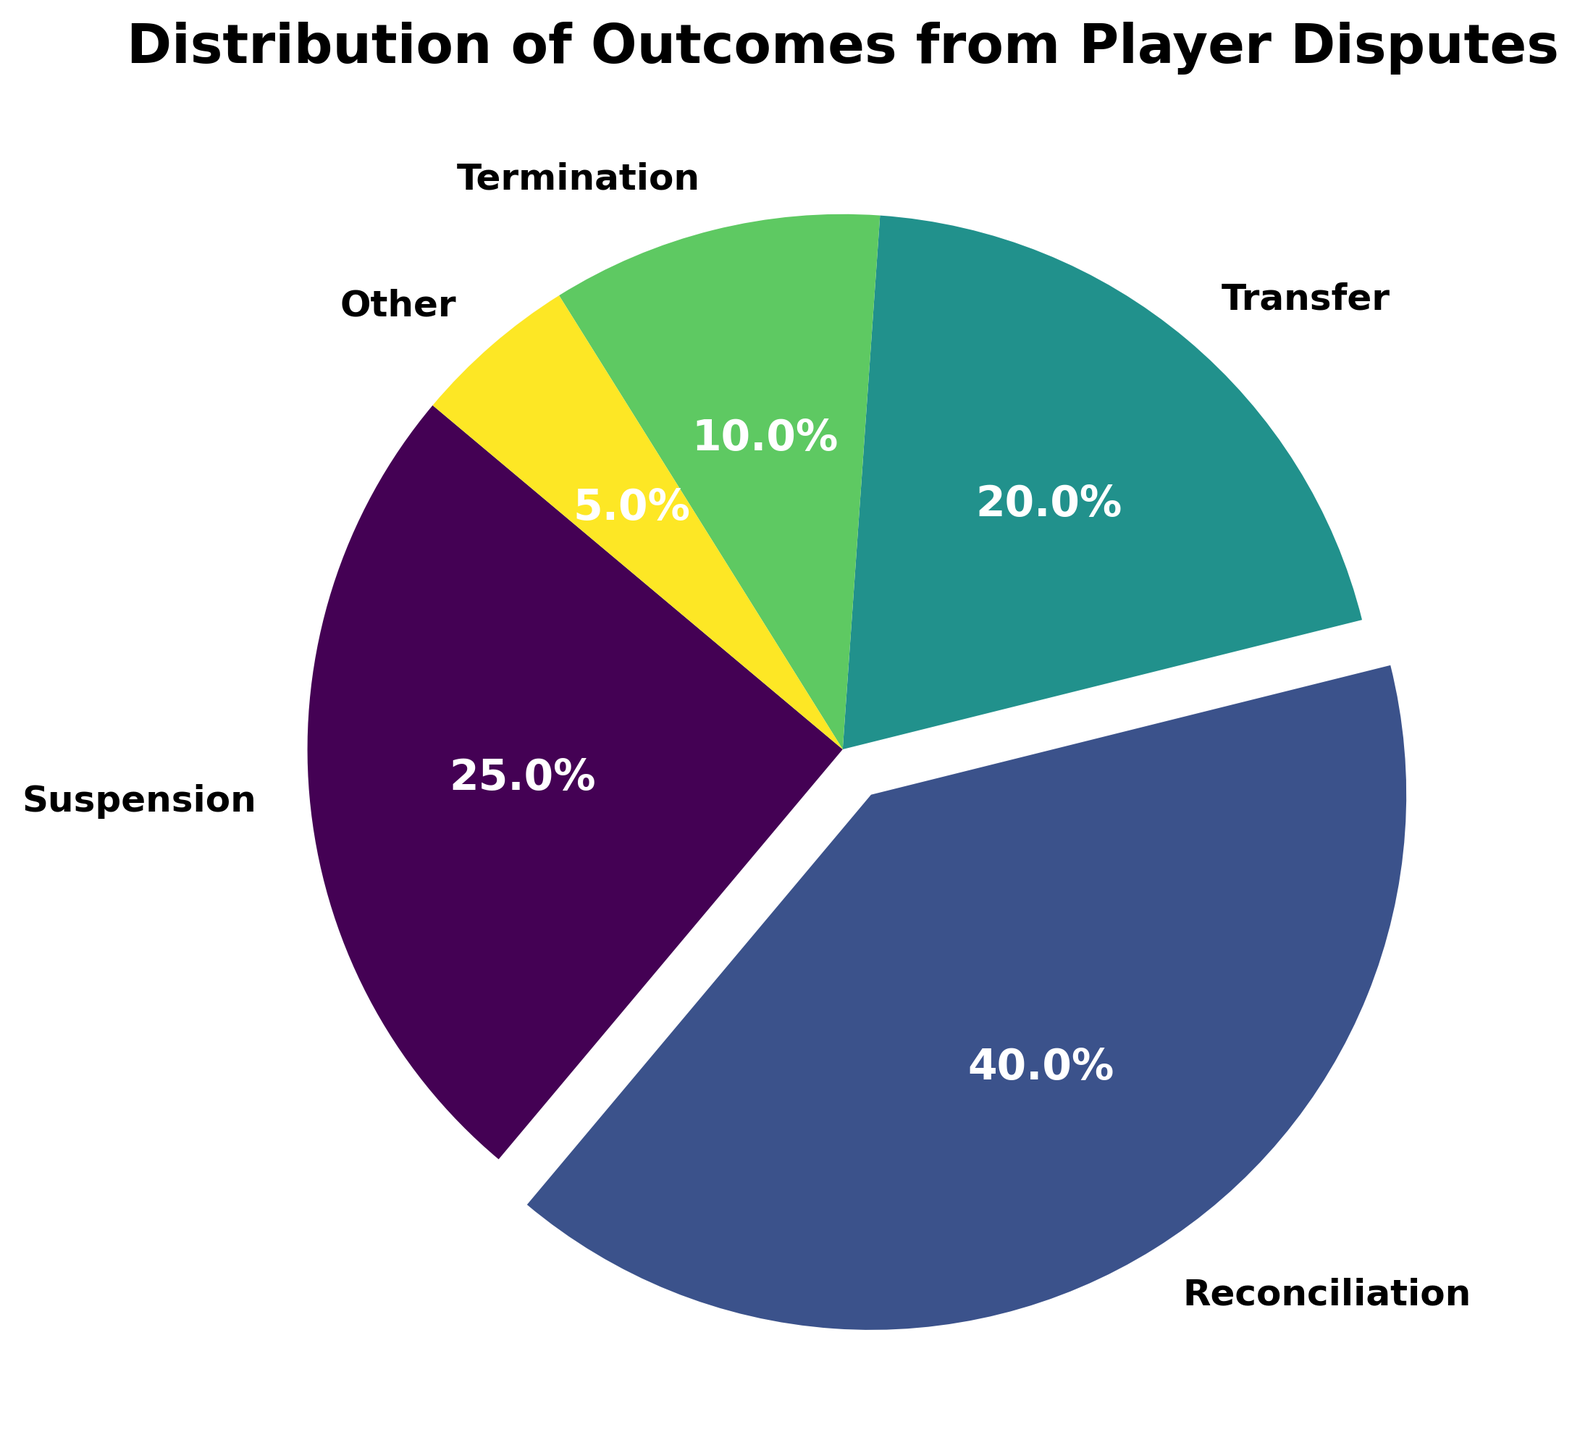Which outcome has the highest percentage? The largest portion of the pie chart represents the outcome with the highest percentage. The label showing the highest percentage (40%) is associated with Reconciliation.
Answer: Reconciliation Which outcome has the lowest percentage? The smallest portion of the pie chart represents the outcome with the lowest percentage. The label showing the lowest percentage (5%) is associated with Other.
Answer: Other What is the combined percentage of Suspension and Transfer outcomes? From the pie chart, Suspension is 25% and Transfer is 20%. Adding these together, 25% + 20% = 45%.
Answer: 45% How much greater is the percentage of Reconciliation compared to Termination? According to the pie chart, the percentages for Reconciliation and Termination are 40% and 10%, respectively. To find how much greater Reconciliation is, subtract Termination from Reconciliation (40% - 10% = 30%).
Answer: 30% Which outcomes account for over half of the total percentage? We need to sum the outcomes that have the largest percentages until the total exceeds 50%. Reconciliation (40%) and Suspension (25%) make up more than half when combined (40% + 25% = 65%).
Answer: Reconciliation and Suspension What is the total percentage of outcomes that are not Reconciliation? To get the percentage of outcomes that are not Reconciliation, subtract the percentage of Reconciliation from 100%. The percentage for Reconciliation is 40%, so 100% - 40% = 60%.
Answer: 60% Which outcome has the second-highest percentage? In the pie chart, the labels indicate that the outcome with the second-highest percentage is Suspension, which has 25% (higher than Transfer, Termination, and Other but less than Reconciliation).
Answer: Suspension What is the difference in percentage between Transfer and Other outcomes? The pie chart shows Transfer at 20% and Other at 5%. Subtract the smaller percentage (Other) from the larger one (Transfer), 20% - 5% = 15%.
Answer: 15% How many outcomes have a percentage of 20% or higher? By checking each segment of the pie chart, Suspension (25%), Reconciliation (40%), and Transfer (20%) all meet or exceed 20%. The outcomes are Reconciliation, Suspension, and Transfer.
Answer: 3 Is the percentage for Termination closer to Transfer or Other? The percentages are Termination (10%), Transfer (20%), and Other (5%). Finding the difference: Termination to Transfer is 20% - 10% = 10%; Termination to Other is 10% - 5% = 5%. Termination is closer to Other by 5%.
Answer: Other 